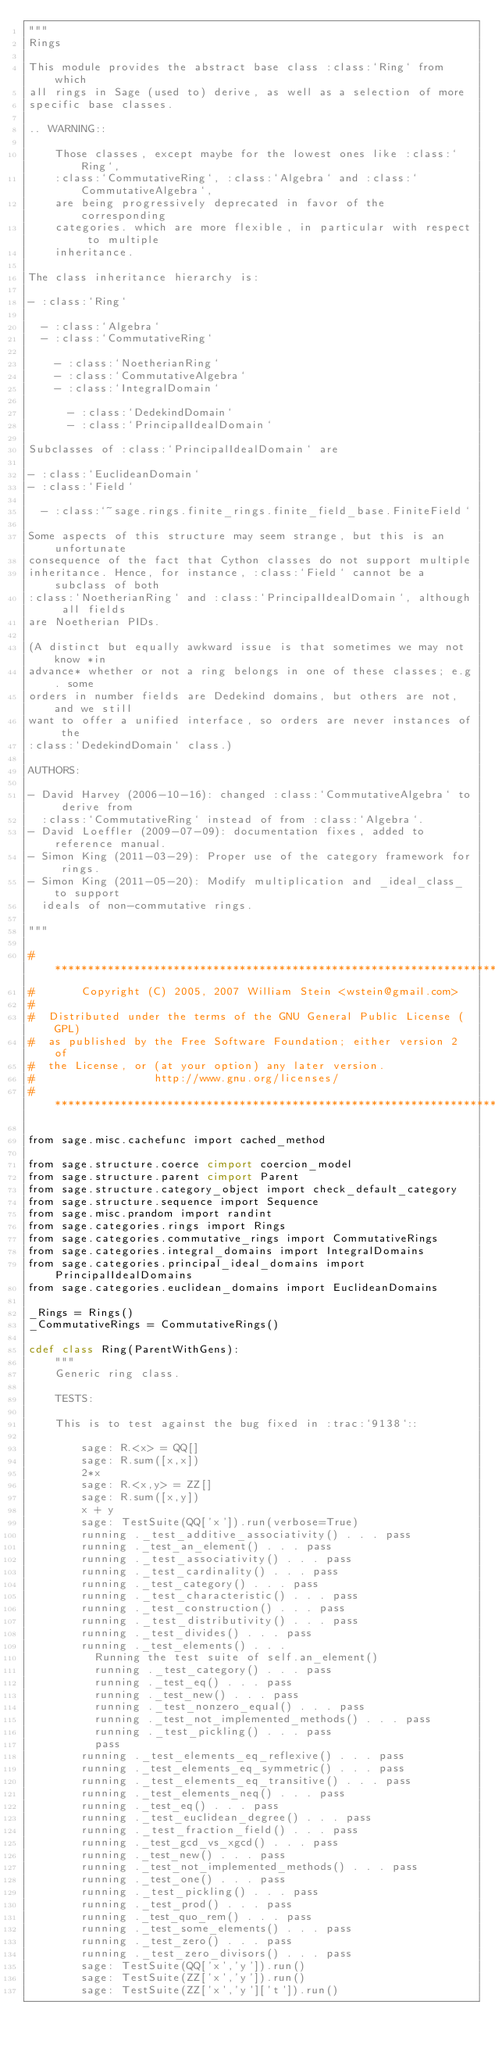Convert code to text. <code><loc_0><loc_0><loc_500><loc_500><_Cython_>"""
Rings

This module provides the abstract base class :class:`Ring` from which
all rings in Sage (used to) derive, as well as a selection of more
specific base classes.

.. WARNING::

    Those classes, except maybe for the lowest ones like :class:`Ring`,
    :class:`CommutativeRing`, :class:`Algebra` and :class:`CommutativeAlgebra`,
    are being progressively deprecated in favor of the corresponding
    categories. which are more flexible, in particular with respect to multiple
    inheritance.

The class inheritance hierarchy is:

- :class:`Ring`

  - :class:`Algebra`
  - :class:`CommutativeRing`

    - :class:`NoetherianRing`
    - :class:`CommutativeAlgebra`
    - :class:`IntegralDomain`

      - :class:`DedekindDomain`
      - :class:`PrincipalIdealDomain`

Subclasses of :class:`PrincipalIdealDomain` are

- :class:`EuclideanDomain`
- :class:`Field`

  - :class:`~sage.rings.finite_rings.finite_field_base.FiniteField`

Some aspects of this structure may seem strange, but this is an unfortunate
consequence of the fact that Cython classes do not support multiple
inheritance. Hence, for instance, :class:`Field` cannot be a subclass of both
:class:`NoetherianRing` and :class:`PrincipalIdealDomain`, although all fields
are Noetherian PIDs.

(A distinct but equally awkward issue is that sometimes we may not know *in
advance* whether or not a ring belongs in one of these classes; e.g. some
orders in number fields are Dedekind domains, but others are not, and we still
want to offer a unified interface, so orders are never instances of the
:class:`DedekindDomain` class.)

AUTHORS:

- David Harvey (2006-10-16): changed :class:`CommutativeAlgebra` to derive from
  :class:`CommutativeRing` instead of from :class:`Algebra`.
- David Loeffler (2009-07-09): documentation fixes, added to reference manual.
- Simon King (2011-03-29): Proper use of the category framework for rings.
- Simon King (2011-05-20): Modify multiplication and _ideal_class_ to support
  ideals of non-commutative rings.

"""

#*****************************************************************************
#       Copyright (C) 2005, 2007 William Stein <wstein@gmail.com>
#
#  Distributed under the terms of the GNU General Public License (GPL)
#  as published by the Free Software Foundation; either version 2 of
#  the License, or (at your option) any later version.
#                  http://www.gnu.org/licenses/
#*****************************************************************************

from sage.misc.cachefunc import cached_method

from sage.structure.coerce cimport coercion_model
from sage.structure.parent cimport Parent
from sage.structure.category_object import check_default_category
from sage.structure.sequence import Sequence
from sage.misc.prandom import randint
from sage.categories.rings import Rings
from sage.categories.commutative_rings import CommutativeRings
from sage.categories.integral_domains import IntegralDomains
from sage.categories.principal_ideal_domains import PrincipalIdealDomains
from sage.categories.euclidean_domains import EuclideanDomains

_Rings = Rings()
_CommutativeRings = CommutativeRings()

cdef class Ring(ParentWithGens):
    """
    Generic ring class.

    TESTS:

    This is to test against the bug fixed in :trac:`9138`::

        sage: R.<x> = QQ[]
        sage: R.sum([x,x])
        2*x
        sage: R.<x,y> = ZZ[]
        sage: R.sum([x,y])
        x + y
        sage: TestSuite(QQ['x']).run(verbose=True)
        running ._test_additive_associativity() . . . pass
        running ._test_an_element() . . . pass
        running ._test_associativity() . . . pass
        running ._test_cardinality() . . . pass
        running ._test_category() . . . pass
        running ._test_characteristic() . . . pass
        running ._test_construction() . . . pass
        running ._test_distributivity() . . . pass
        running ._test_divides() . . . pass
        running ._test_elements() . . .
          Running the test suite of self.an_element()
          running ._test_category() . . . pass
          running ._test_eq() . . . pass
          running ._test_new() . . . pass
          running ._test_nonzero_equal() . . . pass
          running ._test_not_implemented_methods() . . . pass
          running ._test_pickling() . . . pass
          pass
        running ._test_elements_eq_reflexive() . . . pass
        running ._test_elements_eq_symmetric() . . . pass
        running ._test_elements_eq_transitive() . . . pass
        running ._test_elements_neq() . . . pass
        running ._test_eq() . . . pass
        running ._test_euclidean_degree() . . . pass
        running ._test_fraction_field() . . . pass
        running ._test_gcd_vs_xgcd() . . . pass
        running ._test_new() . . . pass
        running ._test_not_implemented_methods() . . . pass
        running ._test_one() . . . pass
        running ._test_pickling() . . . pass
        running ._test_prod() . . . pass
        running ._test_quo_rem() . . . pass
        running ._test_some_elements() . . . pass
        running ._test_zero() . . . pass
        running ._test_zero_divisors() . . . pass
        sage: TestSuite(QQ['x','y']).run()
        sage: TestSuite(ZZ['x','y']).run()
        sage: TestSuite(ZZ['x','y']['t']).run()
</code> 